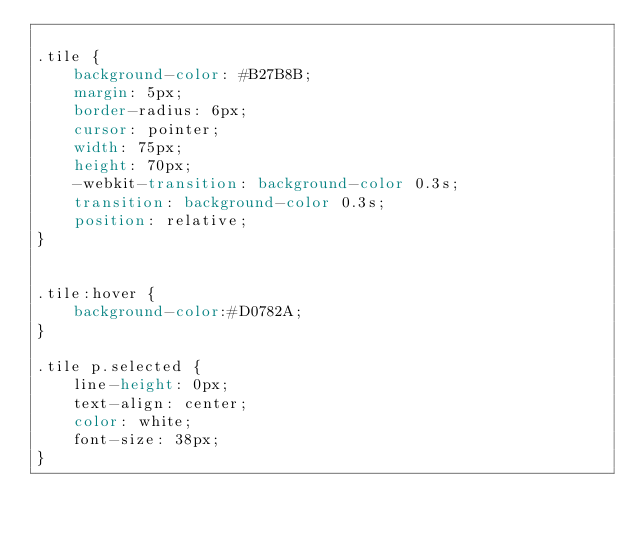Convert code to text. <code><loc_0><loc_0><loc_500><loc_500><_CSS_>
.tile {
    background-color: #B27B8B;
    margin: 5px;
    border-radius: 6px;
    cursor: pointer;
    width: 75px;
    height: 70px;
    -webkit-transition: background-color 0.3s;
    transition: background-color 0.3s;
    position: relative;
}


.tile:hover {
    background-color:#D0782A;
}

.tile p.selected {
    line-height: 0px;
    text-align: center;
    color: white;
    font-size: 38px;
}</code> 